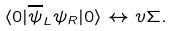<formula> <loc_0><loc_0><loc_500><loc_500>\langle 0 | \overline { \psi } _ { L } \psi _ { R } | 0 \rangle \leftrightarrow v \Sigma .</formula> 